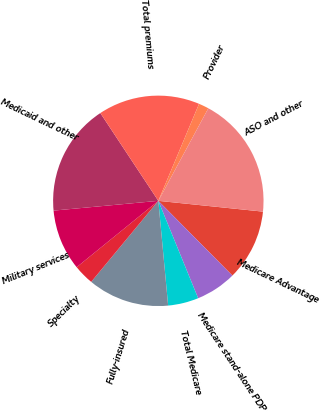<chart> <loc_0><loc_0><loc_500><loc_500><pie_chart><fcel>Medicare Advantage<fcel>Medicare stand-alone PDP<fcel>Total Medicare<fcel>Fully-insured<fcel>Specialty<fcel>Military services<fcel>Medicaid and other<fcel>Total premiums<fcel>Provider<fcel>ASO and other<nl><fcel>10.94%<fcel>6.25%<fcel>4.69%<fcel>12.5%<fcel>3.13%<fcel>9.38%<fcel>17.19%<fcel>15.62%<fcel>1.56%<fcel>18.75%<nl></chart> 